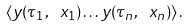<formula> <loc_0><loc_0><loc_500><loc_500>\langle y ( \tau _ { 1 } , \ x _ { 1 } ) \dots y ( \tau _ { n } , \ x _ { n } ) \rangle \, .</formula> 